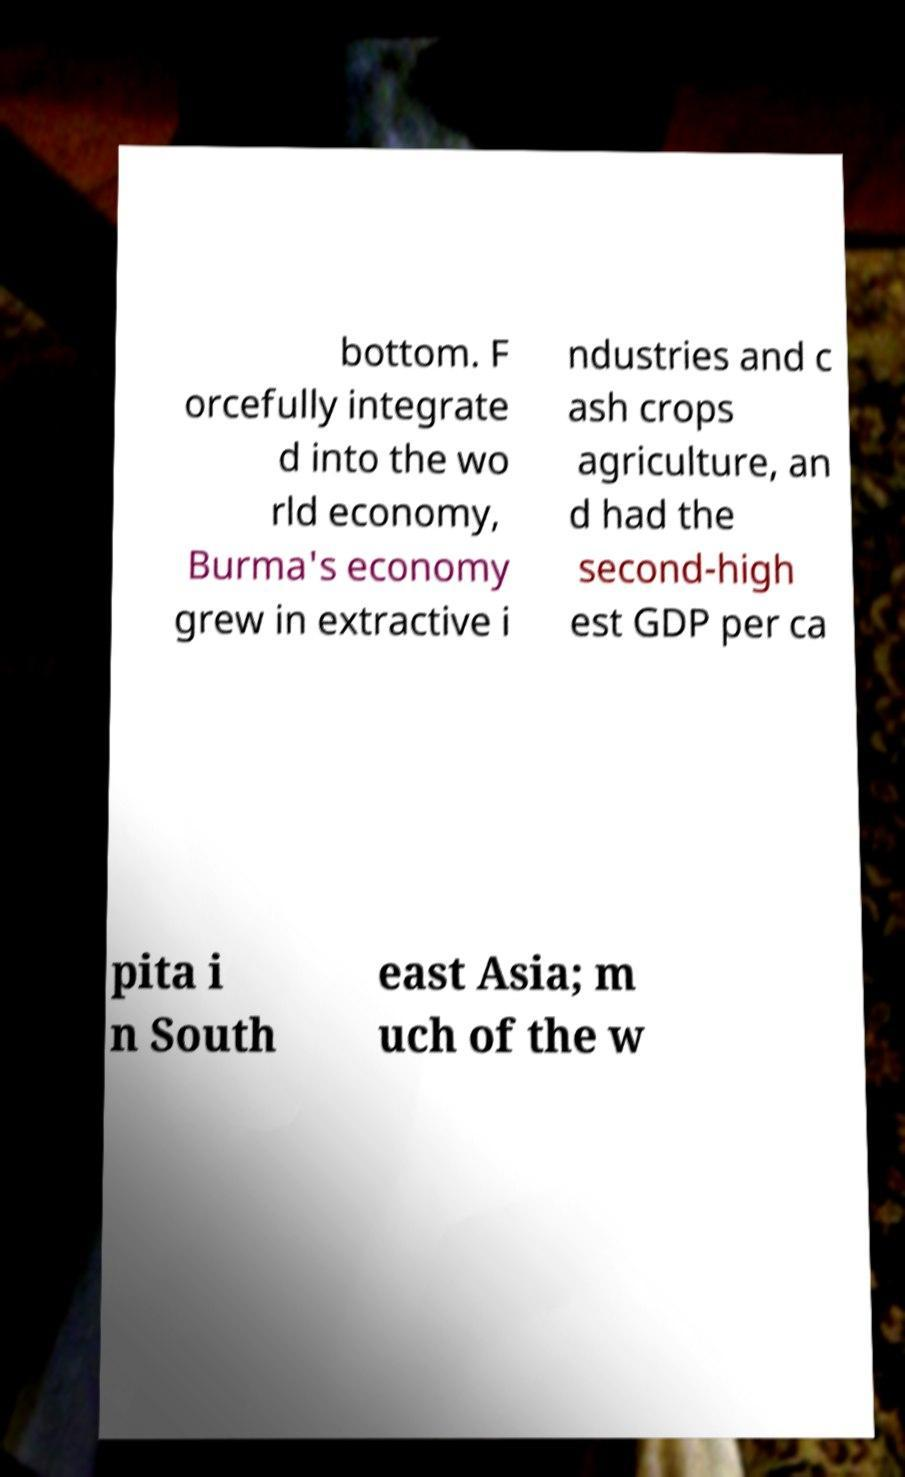Can you accurately transcribe the text from the provided image for me? bottom. F orcefully integrate d into the wo rld economy, Burma's economy grew in extractive i ndustries and c ash crops agriculture, an d had the second-high est GDP per ca pita i n South east Asia; m uch of the w 